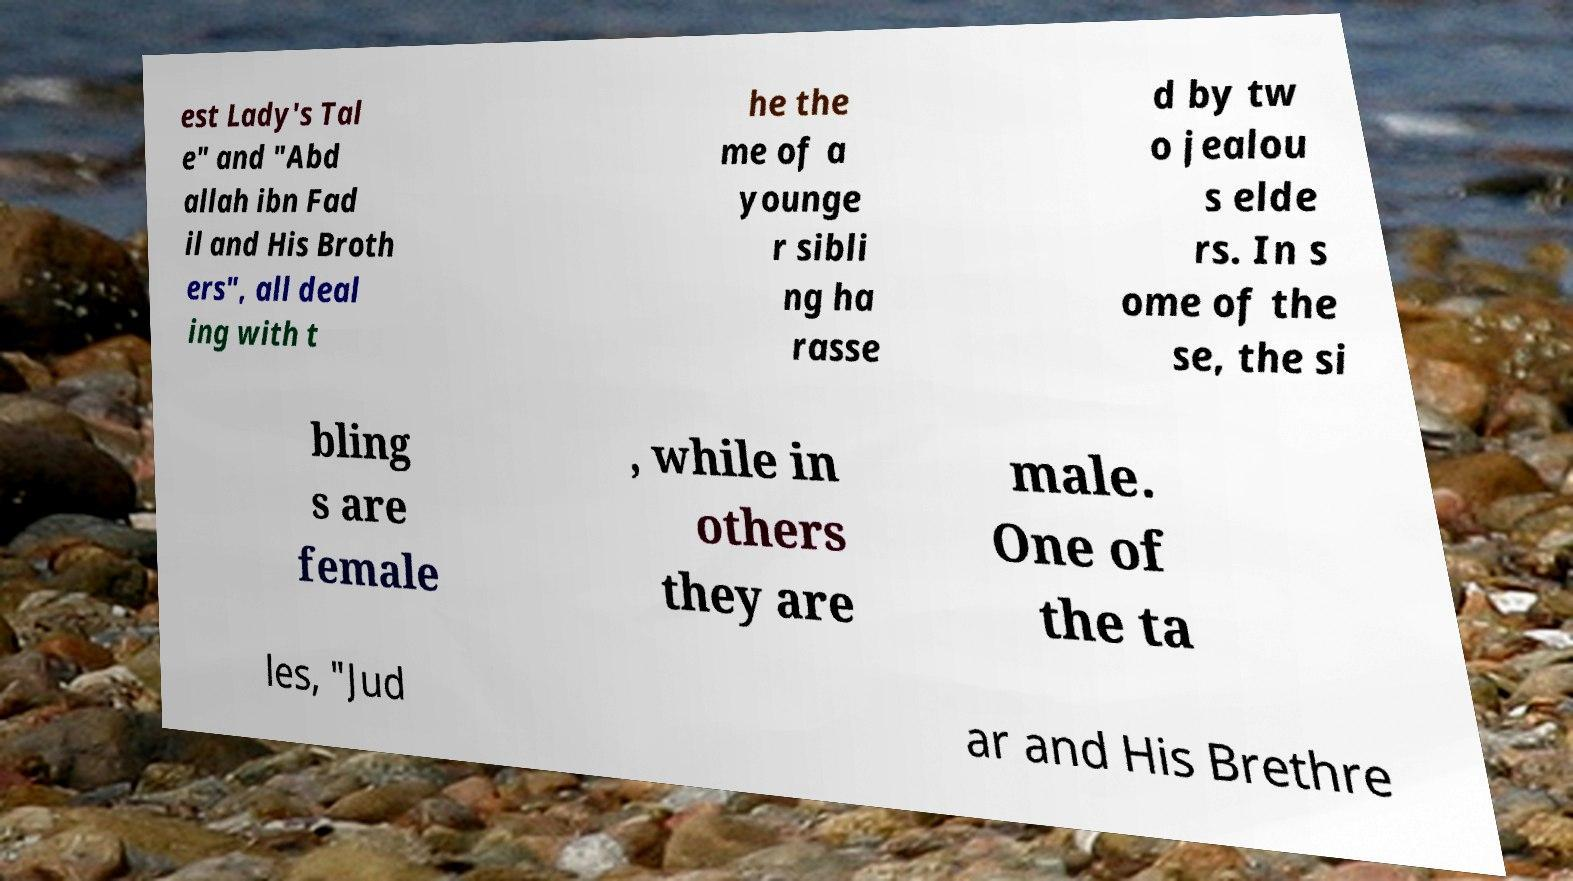Could you assist in decoding the text presented in this image and type it out clearly? est Lady's Tal e" and "Abd allah ibn Fad il and His Broth ers", all deal ing with t he the me of a younge r sibli ng ha rasse d by tw o jealou s elde rs. In s ome of the se, the si bling s are female , while in others they are male. One of the ta les, "Jud ar and His Brethre 